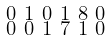<formula> <loc_0><loc_0><loc_500><loc_500>\begin{smallmatrix} 0 & 1 & 0 & 1 & 8 & 0 & \\ 0 & 0 & 1 & 7 & 1 & 0 & \\ \end{smallmatrix}</formula> 